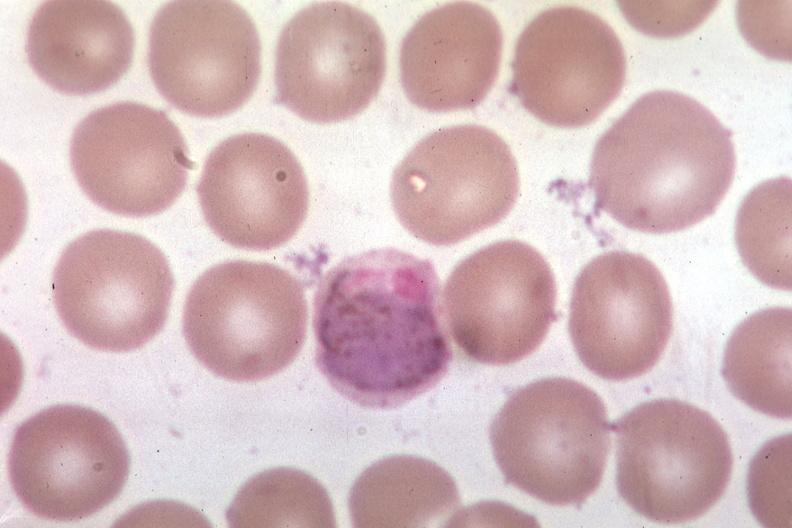s hematologic present?
Answer the question using a single word or phrase. Yes 